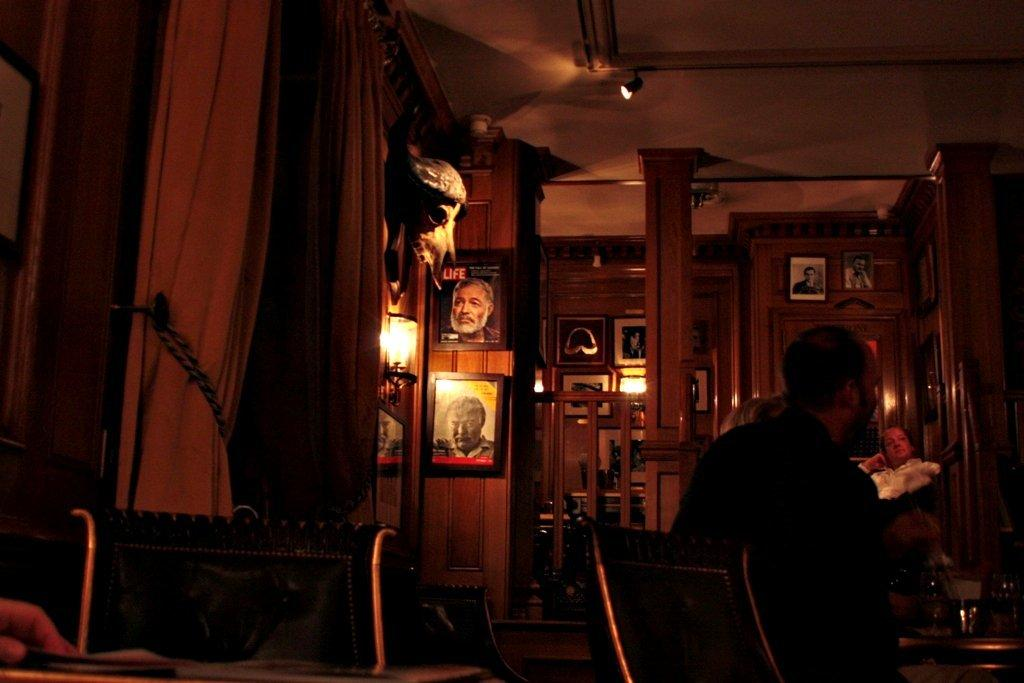What is hanging on the wall in the image? There are photo frames on the wall. What can be seen on the roof in the image? There are light arrangements on the roof. What type of furniture is present in the image? There are sitting chairs in the image. Are there any people in the image? Yes, there are people in the image. What type of balloon can be seen in the pocket of one of the people in the image? There is no balloon or pocket visible in the image. What type of drink is being consumed by the people in the image? There is no drink being consumed by the people in the image. 